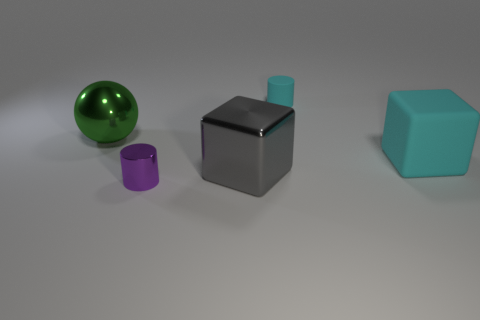Are there more matte things than yellow rubber cubes?
Make the answer very short. Yes. Do the cyan rubber cylinder and the purple cylinder have the same size?
Make the answer very short. Yes. How many objects are either small gray matte cylinders or large gray cubes?
Keep it short and to the point. 1. There is a metallic thing that is behind the large metal object that is to the right of the object that is in front of the big metallic block; what shape is it?
Your answer should be compact. Sphere. Is the small object behind the large green metal sphere made of the same material as the large cube that is in front of the cyan block?
Your answer should be compact. No. There is another object that is the same shape as the tiny metal object; what material is it?
Ensure brevity in your answer.  Rubber. Is there any other thing that is the same size as the purple object?
Offer a very short reply. Yes. Does the small thing behind the tiny purple object have the same shape as the large metallic thing to the right of the small shiny cylinder?
Offer a terse response. No. Are there fewer cyan things behind the small cyan rubber cylinder than green metallic spheres in front of the big shiny block?
Provide a short and direct response. No. What number of other things are the same shape as the small matte thing?
Your answer should be very brief. 1. 